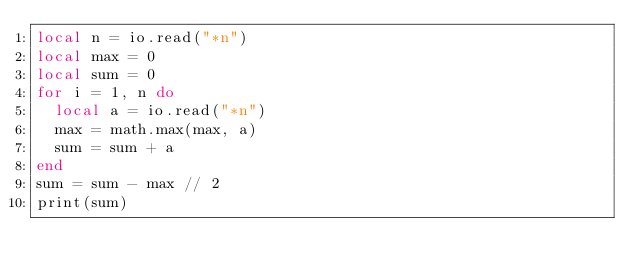Convert code to text. <code><loc_0><loc_0><loc_500><loc_500><_Lua_>local n = io.read("*n")
local max = 0
local sum = 0
for i = 1, n do
  local a = io.read("*n")
  max = math.max(max, a)
  sum = sum + a
end
sum = sum - max // 2
print(sum)
</code> 